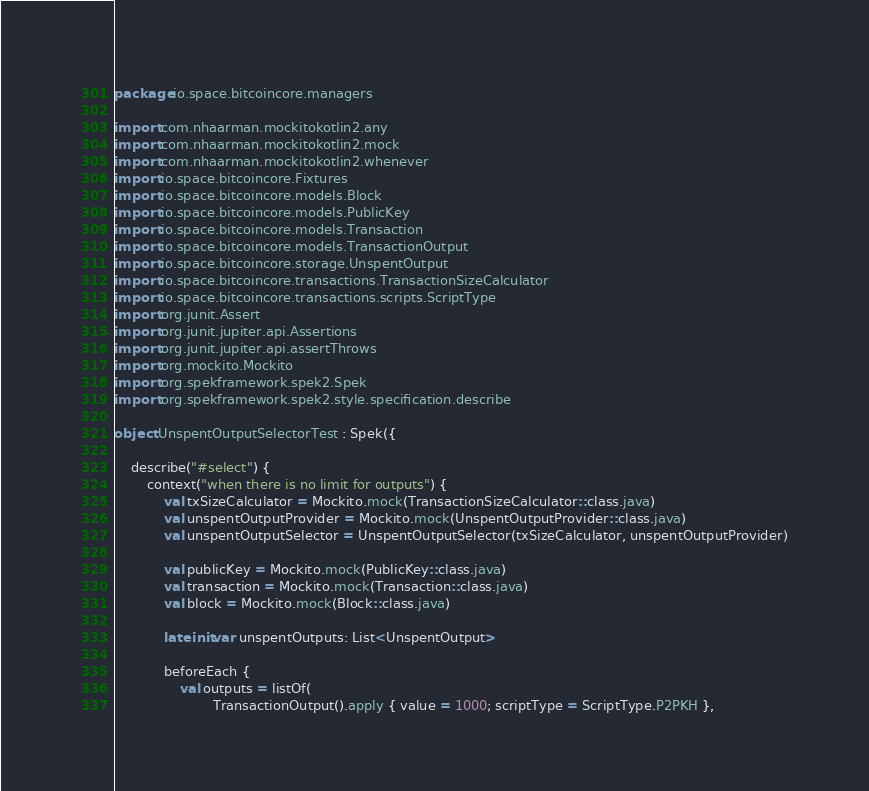<code> <loc_0><loc_0><loc_500><loc_500><_Kotlin_>package io.space.bitcoincore.managers

import com.nhaarman.mockitokotlin2.any
import com.nhaarman.mockitokotlin2.mock
import com.nhaarman.mockitokotlin2.whenever
import io.space.bitcoincore.Fixtures
import io.space.bitcoincore.models.Block
import io.space.bitcoincore.models.PublicKey
import io.space.bitcoincore.models.Transaction
import io.space.bitcoincore.models.TransactionOutput
import io.space.bitcoincore.storage.UnspentOutput
import io.space.bitcoincore.transactions.TransactionSizeCalculator
import io.space.bitcoincore.transactions.scripts.ScriptType
import org.junit.Assert
import org.junit.jupiter.api.Assertions
import org.junit.jupiter.api.assertThrows
import org.mockito.Mockito
import org.spekframework.spek2.Spek
import org.spekframework.spek2.style.specification.describe

object UnspentOutputSelectorTest : Spek({

    describe("#select") {
        context("when there is no limit for outputs") {
            val txSizeCalculator = Mockito.mock(TransactionSizeCalculator::class.java)
            val unspentOutputProvider = Mockito.mock(UnspentOutputProvider::class.java)
            val unspentOutputSelector = UnspentOutputSelector(txSizeCalculator, unspentOutputProvider)

            val publicKey = Mockito.mock(PublicKey::class.java)
            val transaction = Mockito.mock(Transaction::class.java)
            val block = Mockito.mock(Block::class.java)

            lateinit var unspentOutputs: List<UnspentOutput>

            beforeEach {
                val outputs = listOf(
                        TransactionOutput().apply { value = 1000; scriptType = ScriptType.P2PKH },</code> 